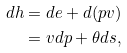<formula> <loc_0><loc_0><loc_500><loc_500>d h & = d e + d ( p v ) \\ & = v d p + \theta d s ,</formula> 